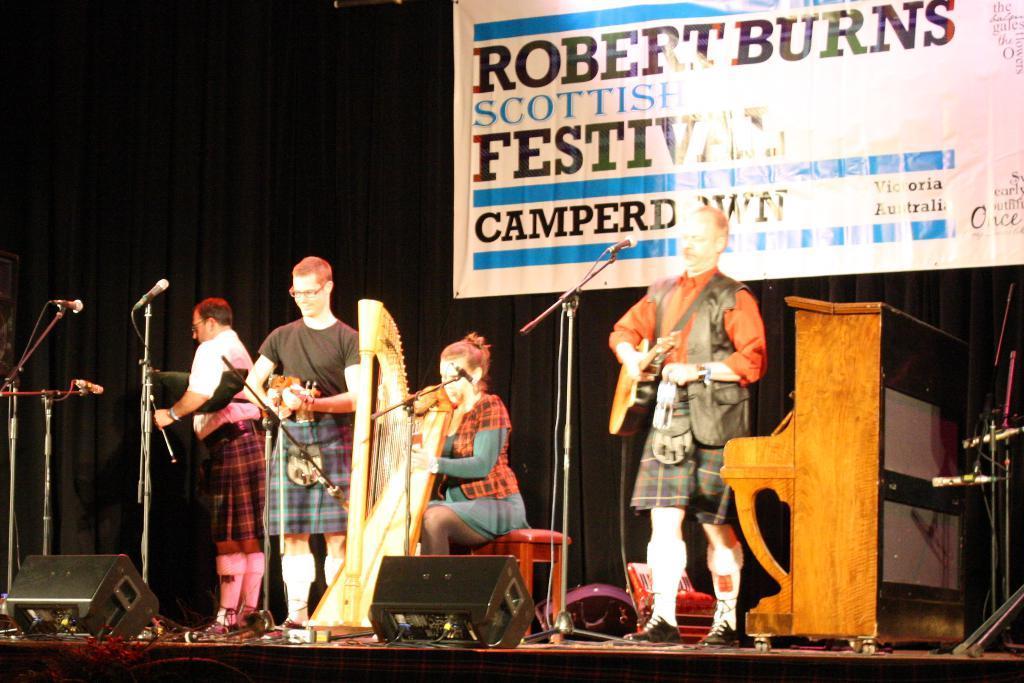How would you summarize this image in a sentence or two? The picture is taken on the stage where people are performing with their instruments and coming to the right corner of the picture one person is standing and holding a guitar beside him there is one wooden table and in the centre of the picture one woman is sitting on the chair and performing a musical instrument and behind her there is a big black curtain and with a poster on it with some text written on it and at the left corner of the picture there is one person standing in front of the microphone. 